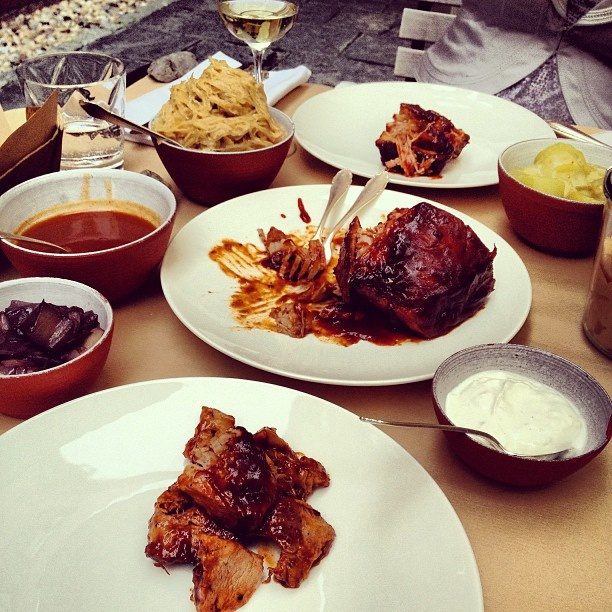Describe the objects in this image and their specific colors. I can see dining table in beige, maroon, and black tones, bowl in black, beige, darkgray, and maroon tones, people in black, darkgray, and gray tones, bowl in black, maroon, tan, and beige tones, and bench in black, gray, purple, and darkgray tones in this image. 